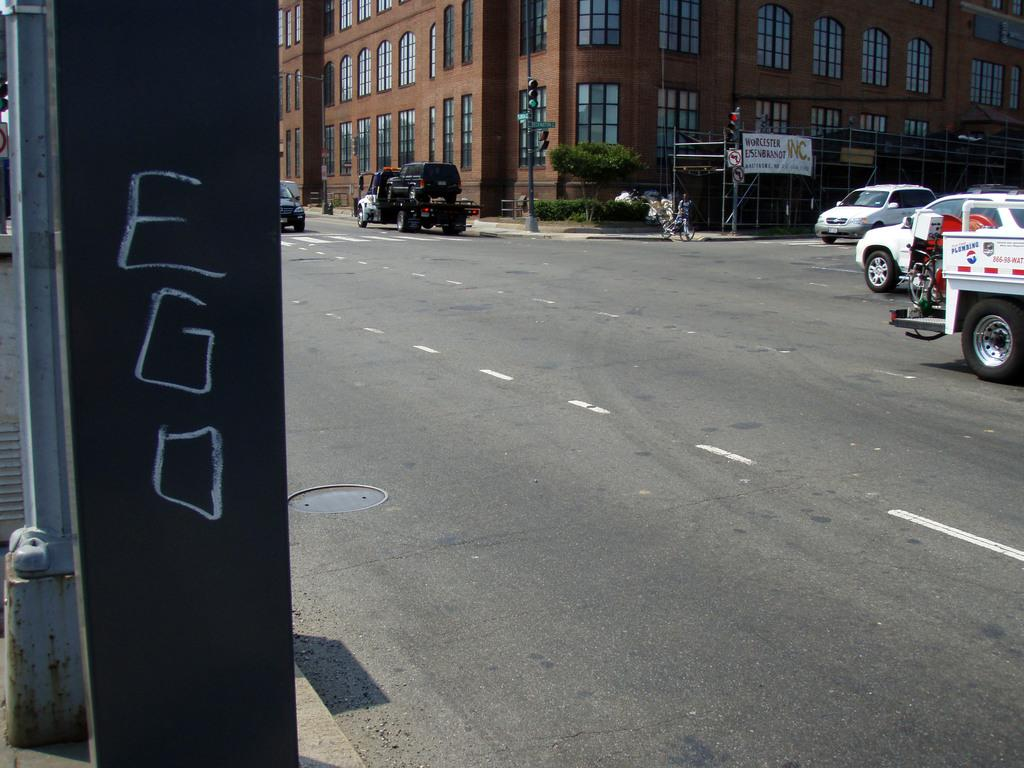What can be seen on the road in the image? There are vehicles on the road in the image. What is hanging or displayed in the image? There is a banner in the image. What structure is present in the image? There is a pole in the image. What controls the flow of traffic in the image? There is a traffic signal in the image. What type of vegetation is visible in the image? There is a tree and plants in the image. What are the rods used for in the image? The purpose of the rods in the image is not specified, but they are present. What else can be seen in the image besides the mentioned objects? There are some objects in the image. What can be seen in the background of the image? There is a building with windows in the background of the image. What historical event is being commemorated by the knee in the image? There is no knee present in the image, and therefore no historical event can be associated with it. 